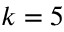Convert formula to latex. <formula><loc_0><loc_0><loc_500><loc_500>k = 5</formula> 